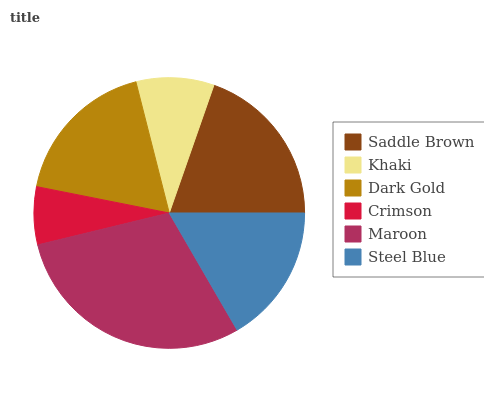Is Crimson the minimum?
Answer yes or no. Yes. Is Maroon the maximum?
Answer yes or no. Yes. Is Khaki the minimum?
Answer yes or no. No. Is Khaki the maximum?
Answer yes or no. No. Is Saddle Brown greater than Khaki?
Answer yes or no. Yes. Is Khaki less than Saddle Brown?
Answer yes or no. Yes. Is Khaki greater than Saddle Brown?
Answer yes or no. No. Is Saddle Brown less than Khaki?
Answer yes or no. No. Is Dark Gold the high median?
Answer yes or no. Yes. Is Steel Blue the low median?
Answer yes or no. Yes. Is Maroon the high median?
Answer yes or no. No. Is Maroon the low median?
Answer yes or no. No. 